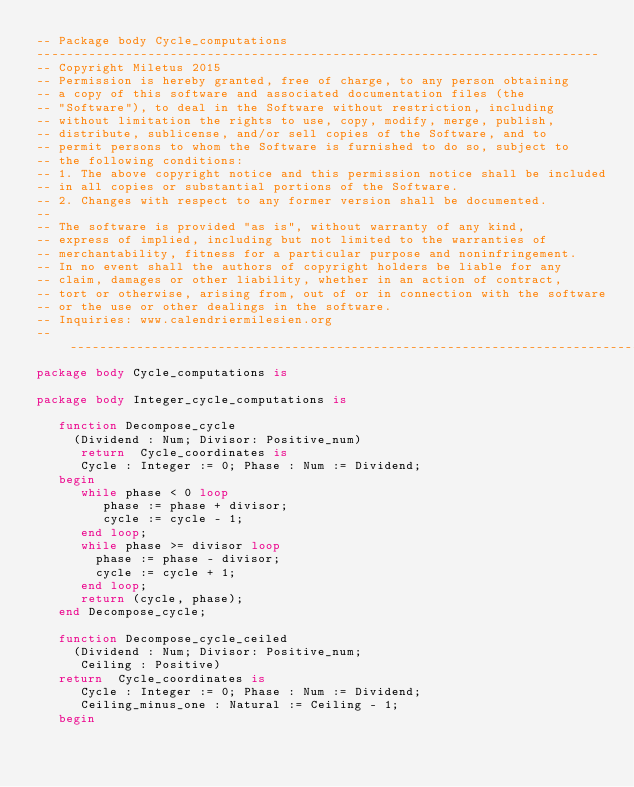Convert code to text. <code><loc_0><loc_0><loc_500><loc_500><_Ada_>-- Package body Cycle_computations
----------------------------------------------------------------------------
-- Copyright Miletus 2015
-- Permission is hereby granted, free of charge, to any person obtaining
-- a copy of this software and associated documentation files (the
-- "Software"), to deal in the Software without restriction, including
-- without limitation the rights to use, copy, modify, merge, publish,
-- distribute, sublicense, and/or sell copies of the Software, and to
-- permit persons to whom the Software is furnished to do so, subject to
-- the following conditions:
-- 1. The above copyright notice and this permission notice shall be included
-- in all copies or substantial portions of the Software.
-- 2. Changes with respect to any former version shall be documented.
--
-- The software is provided "as is", without warranty of any kind,
-- express of implied, including but not limited to the warranties of
-- merchantability, fitness for a particular purpose and noninfringement.
-- In no event shall the authors of copyright holders be liable for any
-- claim, damages or other liability, whether in an action of contract,
-- tort or otherwise, arising from, out of or in connection with the software
-- or the use or other dealings in the software.
-- Inquiries: www.calendriermilesien.org
-------------------------------------------------------------------------------
package body Cycle_computations is

package body Integer_cycle_computations is

   function Decompose_cycle
     (Dividend : Num; Divisor: Positive_num)
      return  Cycle_coordinates is
      Cycle : Integer := 0; Phase : Num := Dividend;
   begin
      while phase < 0 loop
         phase := phase + divisor;
         cycle := cycle - 1;
      end loop;
      while phase >= divisor loop
        phase := phase - divisor;
        cycle := cycle + 1;
      end loop;
      return (cycle, phase);
   end Decompose_cycle;

   function Decompose_cycle_ceiled
     (Dividend : Num; Divisor: Positive_num;
      Ceiling : Positive)
   return  Cycle_coordinates is
      Cycle : Integer := 0; Phase : Num := Dividend;
      Ceiling_minus_one : Natural := Ceiling - 1;
   begin</code> 